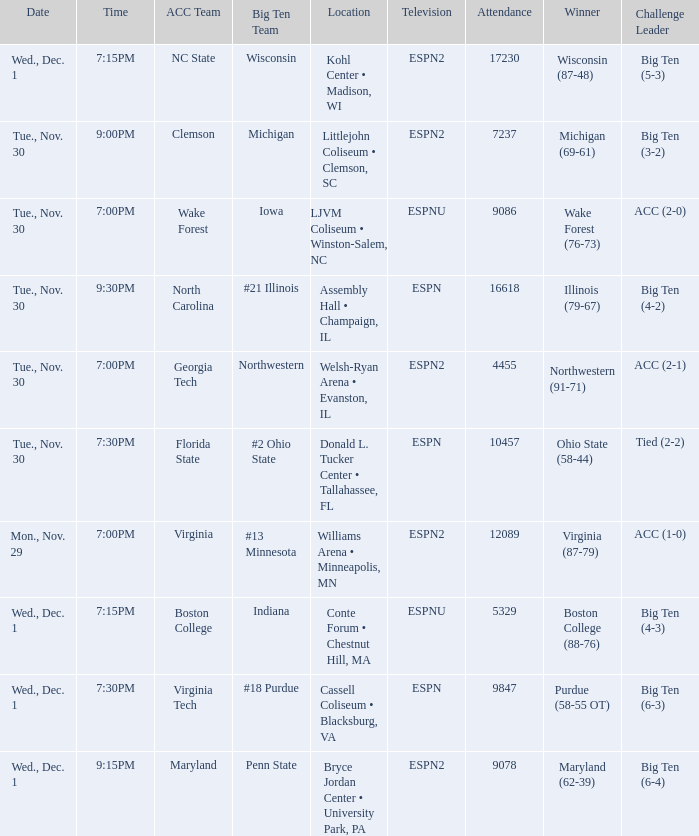Where did the games that had Wake Forest as Acc Team take place? LJVM Coliseum • Winston-Salem, NC. 